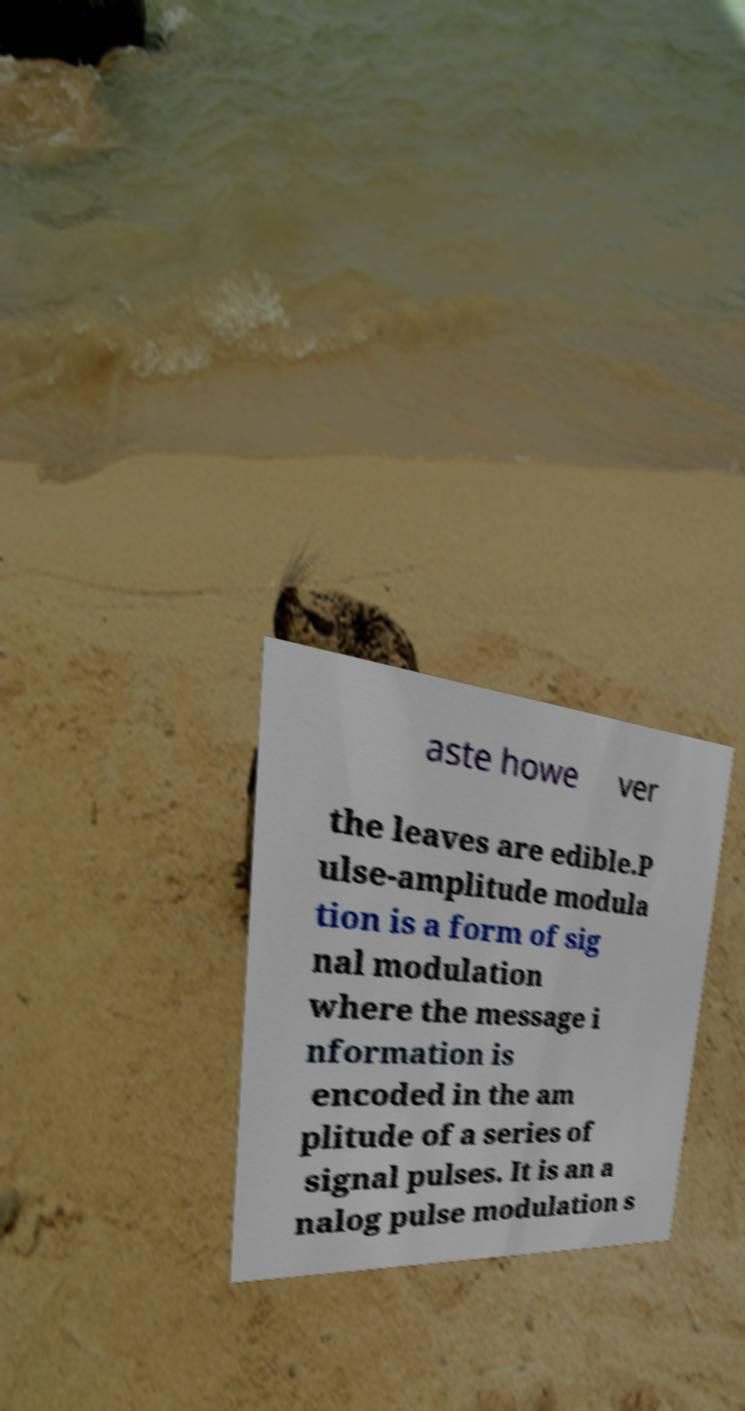What messages or text are displayed in this image? I need them in a readable, typed format. aste howe ver the leaves are edible.P ulse-amplitude modula tion is a form of sig nal modulation where the message i nformation is encoded in the am plitude of a series of signal pulses. It is an a nalog pulse modulation s 